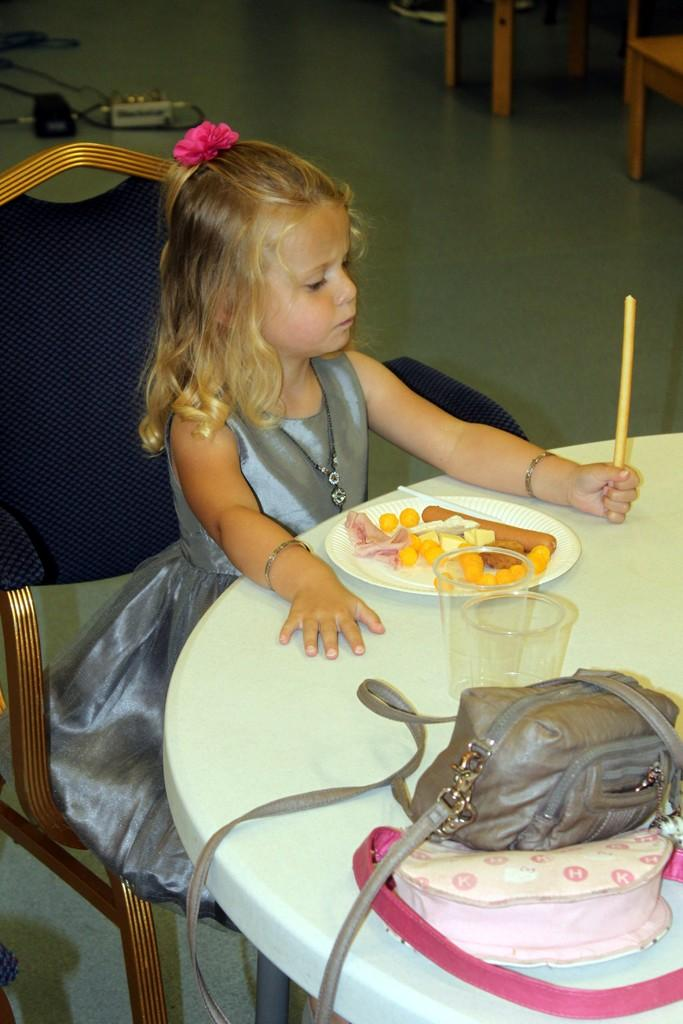What is the girl in the image doing? The girl is sitting in a chair in the image. What can be seen on the table in the image? There is a plate, food, glasses, bags, and a stick on the table in the image. How many chairs are visible in the image? There are chairs in the background of the image. What type of sack is being used for the birthday meeting in the image? There is no sack, birthday, or meeting present in the image. 